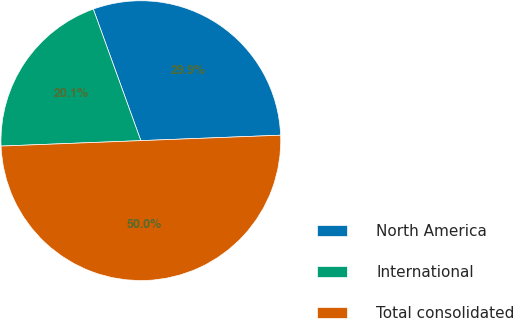Convert chart. <chart><loc_0><loc_0><loc_500><loc_500><pie_chart><fcel>North America<fcel>International<fcel>Total consolidated<nl><fcel>29.9%<fcel>20.1%<fcel>50.0%<nl></chart> 